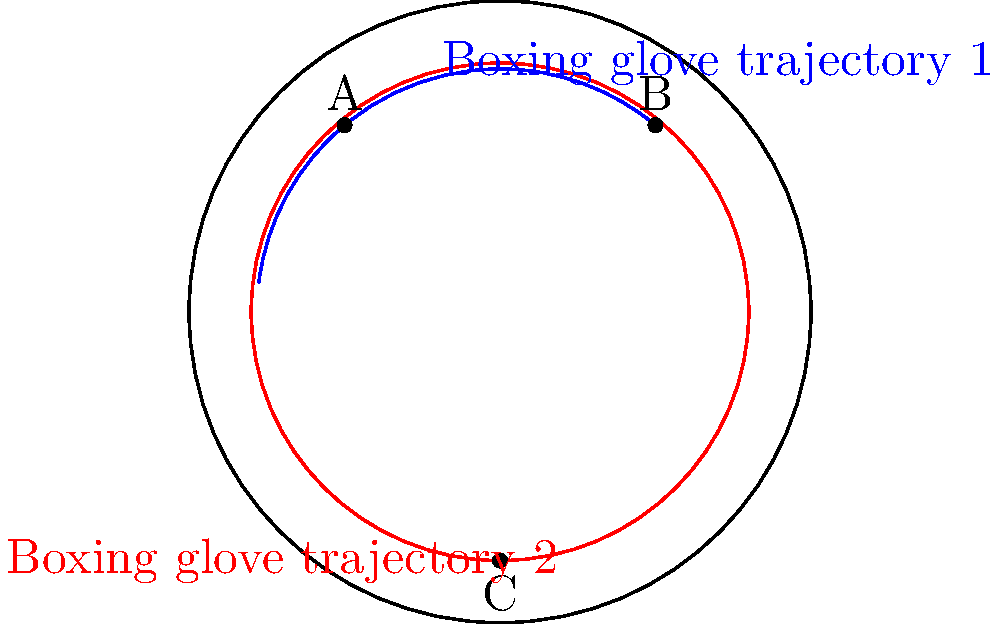In the Poincaré disk model of hyperbolic geometry shown above, two boxing glove trajectories are represented by the blue arcs passing through points A and B. A third trajectory is shown in red, passing through point C. Which of the following statements is true about these trajectories in hyperbolic space? Let's analyze this step-by-step:

1. In the Poincaré disk model, straight lines in hyperbolic space are represented by either diameters of the disk or circular arcs that are perpendicular to the boundary circle.

2. The blue arcs passing through points A and B are circular arcs that meet the boundary circle at right angles. These represent straight lines in hyperbolic space.

3. The red arc passing through point C is also a circular arc meeting the boundary circle at right angles, representing another straight line in hyperbolic space.

4. In Euclidean geometry, we would say that parallel lines never intersect. However, in hyperbolic geometry, the concept of parallelism is different.

5. In hyperbolic geometry, given a line and a point not on that line, there are infinitely many lines passing through the point that do not intersect the given line. These are all considered parallel to the original line.

6. Looking at the diagram, we can see that the red line does not intersect either of the blue lines within the disk. This means that in hyperbolic space, the red line is parallel to both blue lines.

7. However, the two blue lines, while appearing to be parallel in the Euclidean sense, actually diverge from each other in hyperbolic space. They will never intersect, but they are not considered parallel in hyperbolic geometry.

Therefore, in hyperbolic space, the red trajectory (passing through C) is parallel to both blue trajectories, but the two blue trajectories are not parallel to each other.
Answer: The red trajectory is parallel to both blue trajectories, but the blue trajectories are not parallel to each other. 